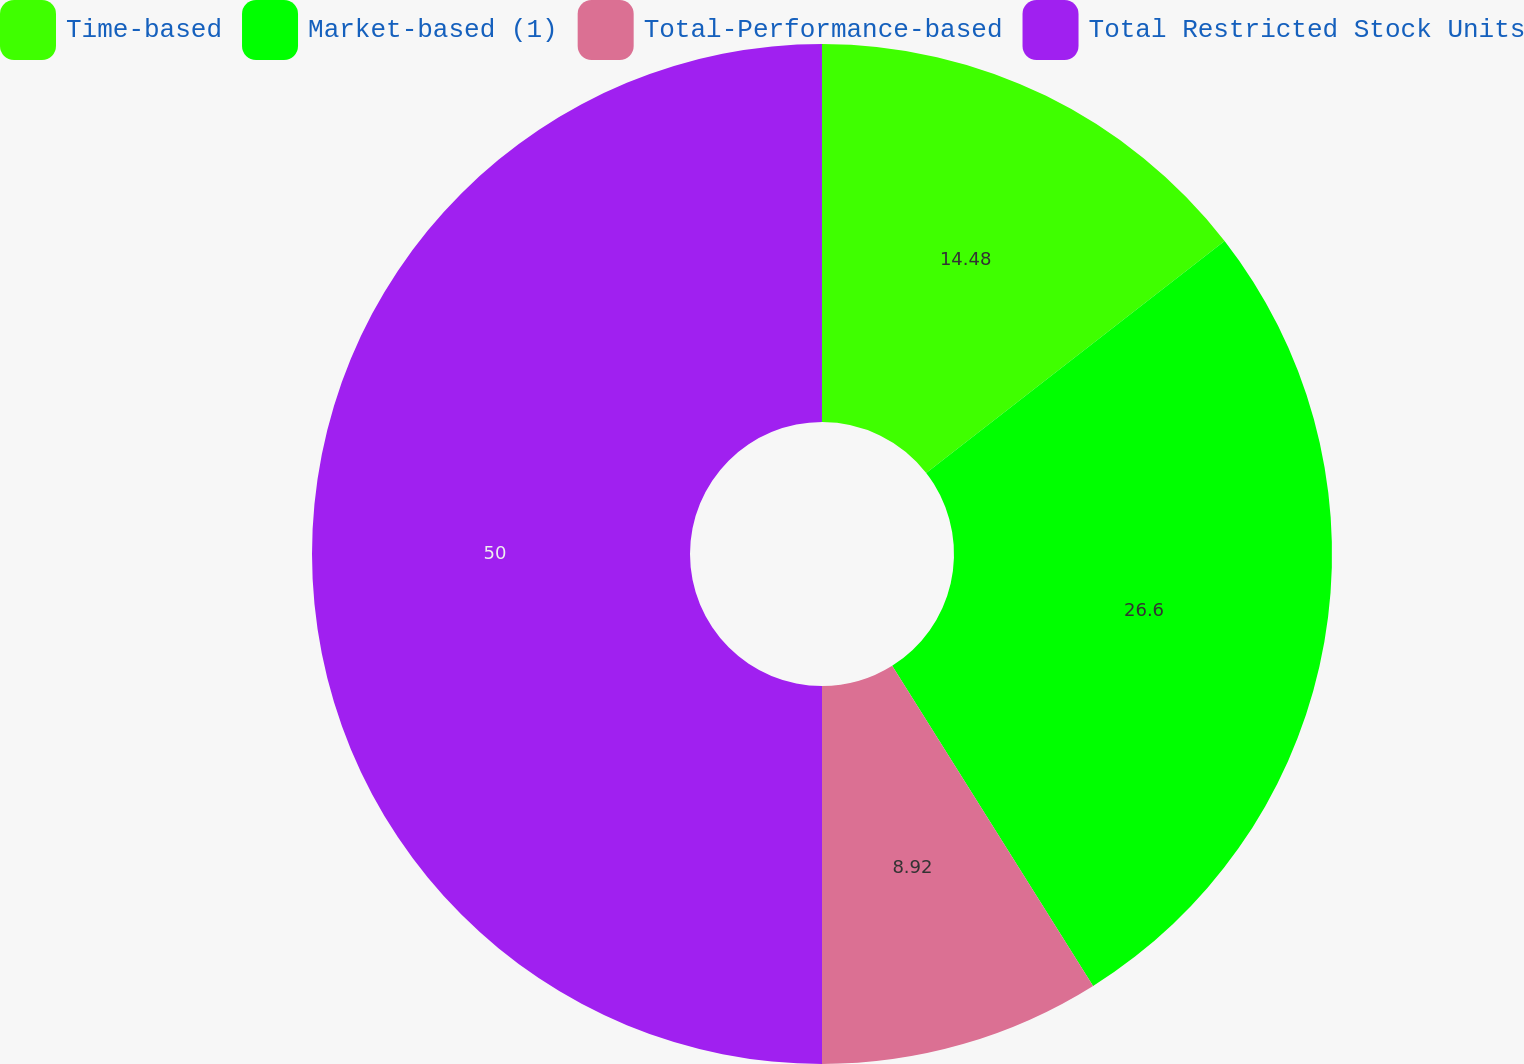<chart> <loc_0><loc_0><loc_500><loc_500><pie_chart><fcel>Time-based<fcel>Market-based (1)<fcel>Total-Performance-based<fcel>Total Restricted Stock Units<nl><fcel>14.48%<fcel>26.6%<fcel>8.92%<fcel>50.0%<nl></chart> 